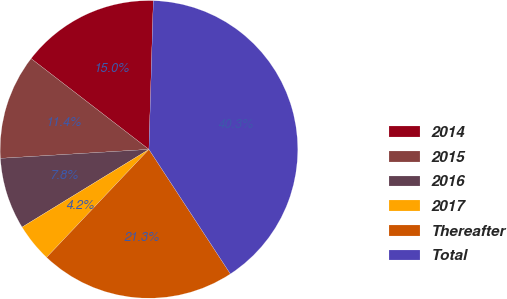<chart> <loc_0><loc_0><loc_500><loc_500><pie_chart><fcel>2014<fcel>2015<fcel>2016<fcel>2017<fcel>Thereafter<fcel>Total<nl><fcel>15.02%<fcel>11.41%<fcel>7.79%<fcel>4.18%<fcel>21.29%<fcel>40.31%<nl></chart> 